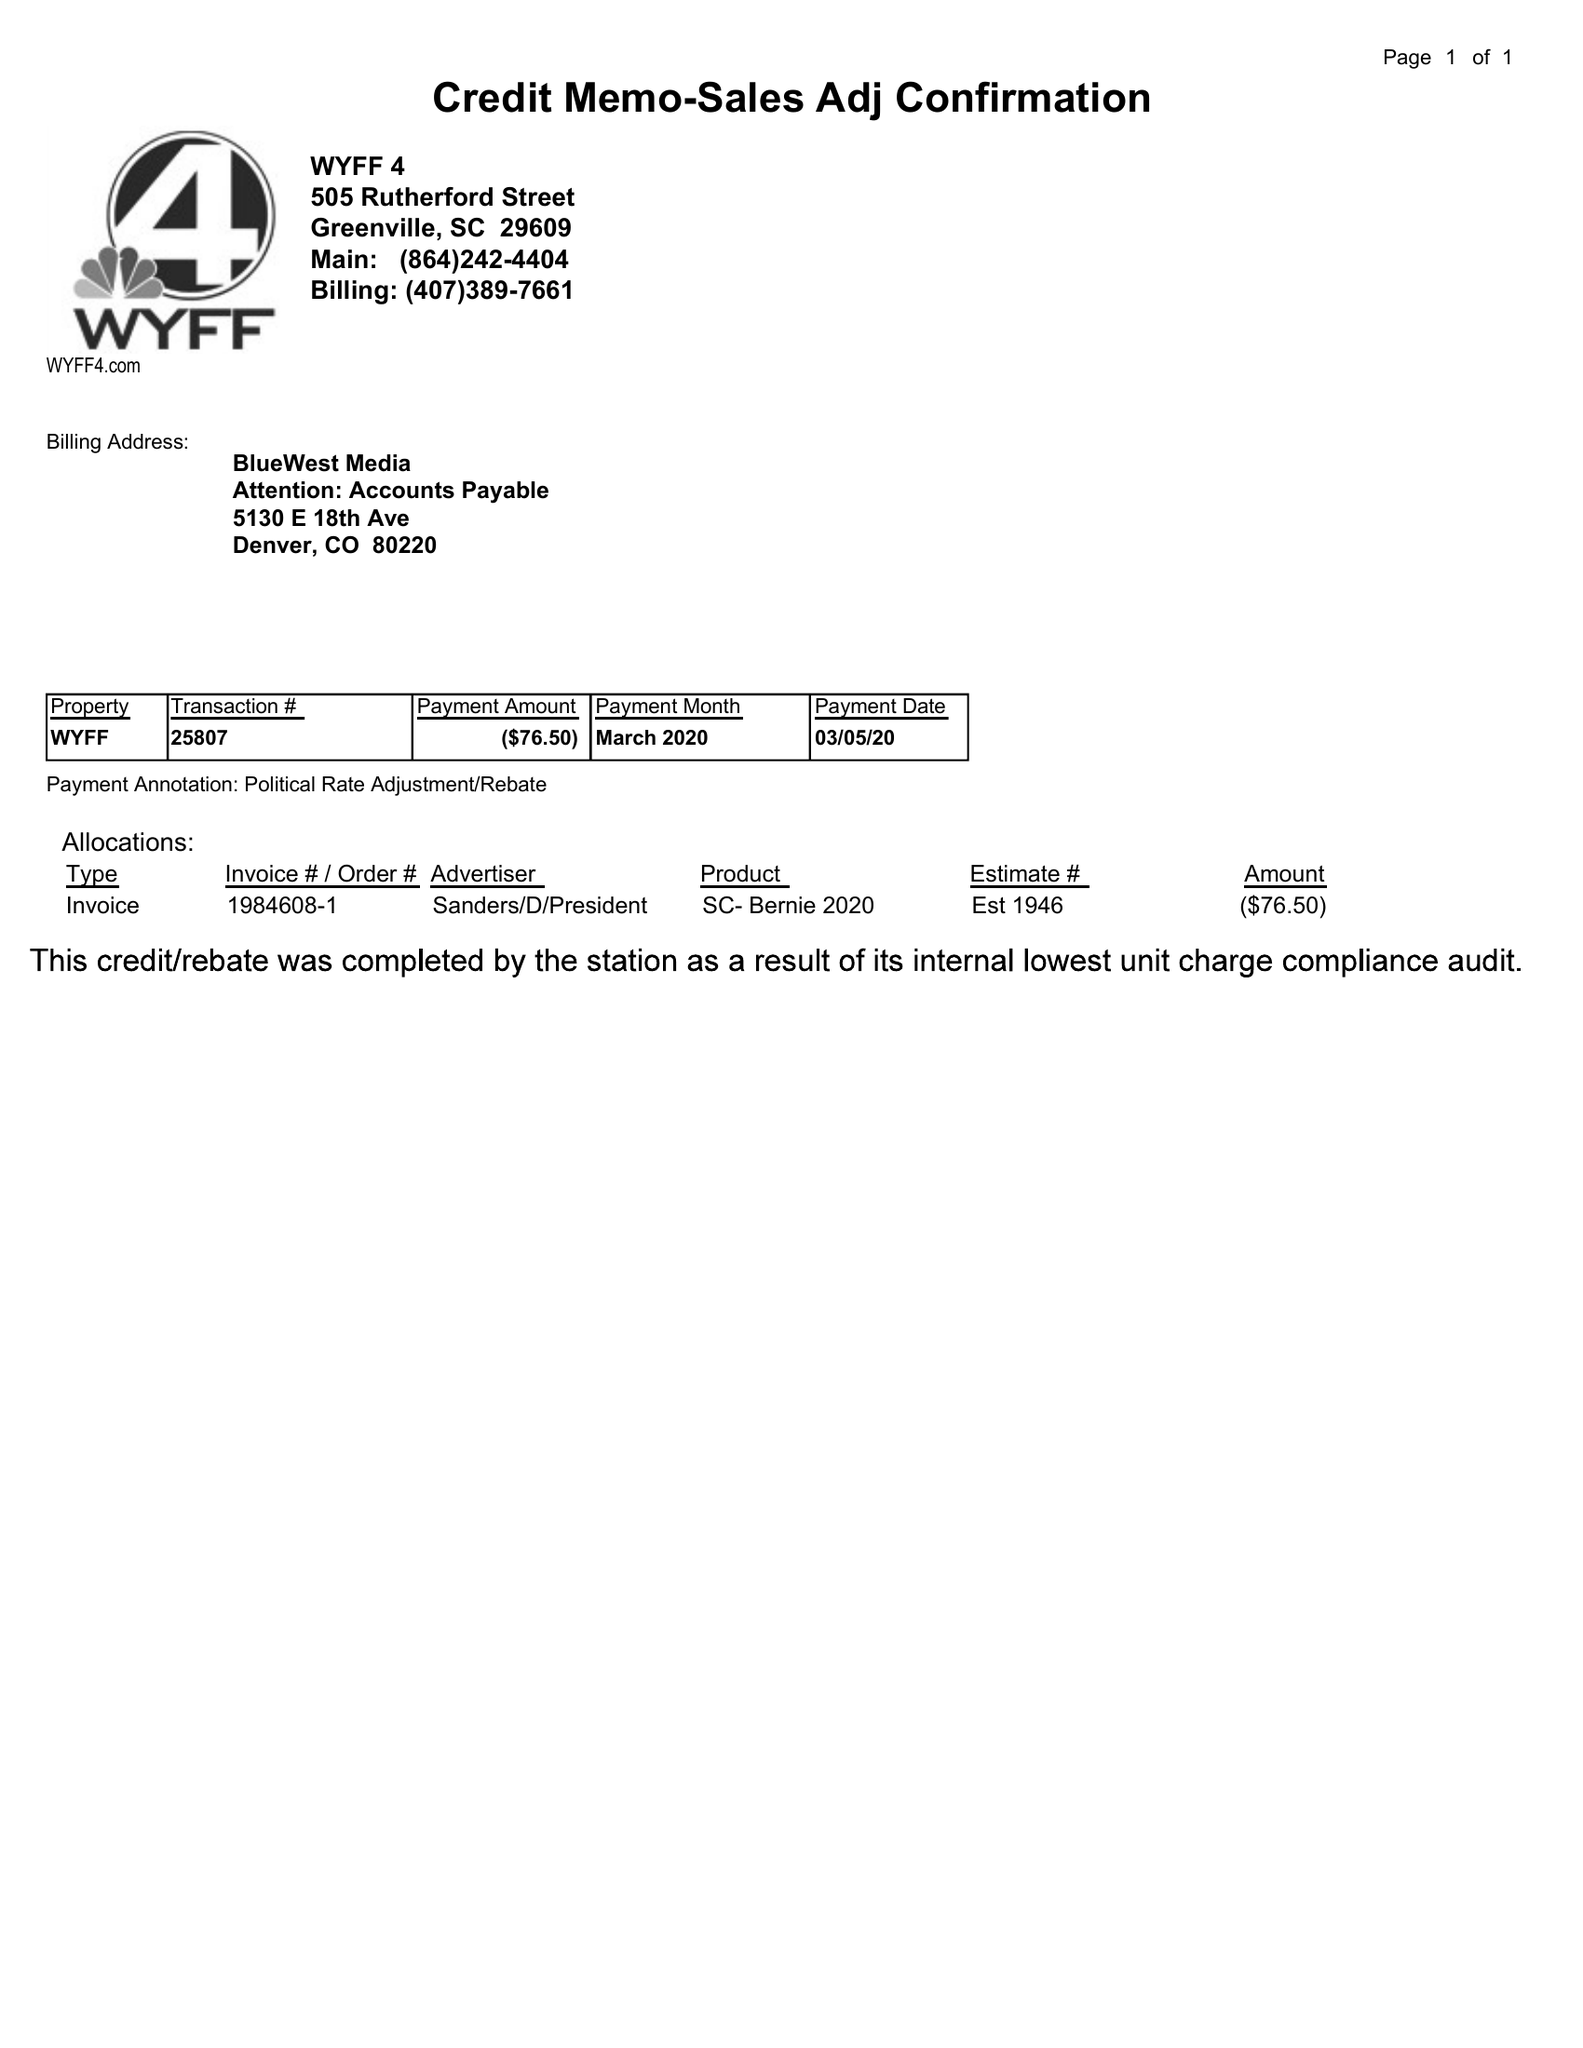What is the value for the advertiser?
Answer the question using a single word or phrase. SANDERS/D/PRESIDENT 